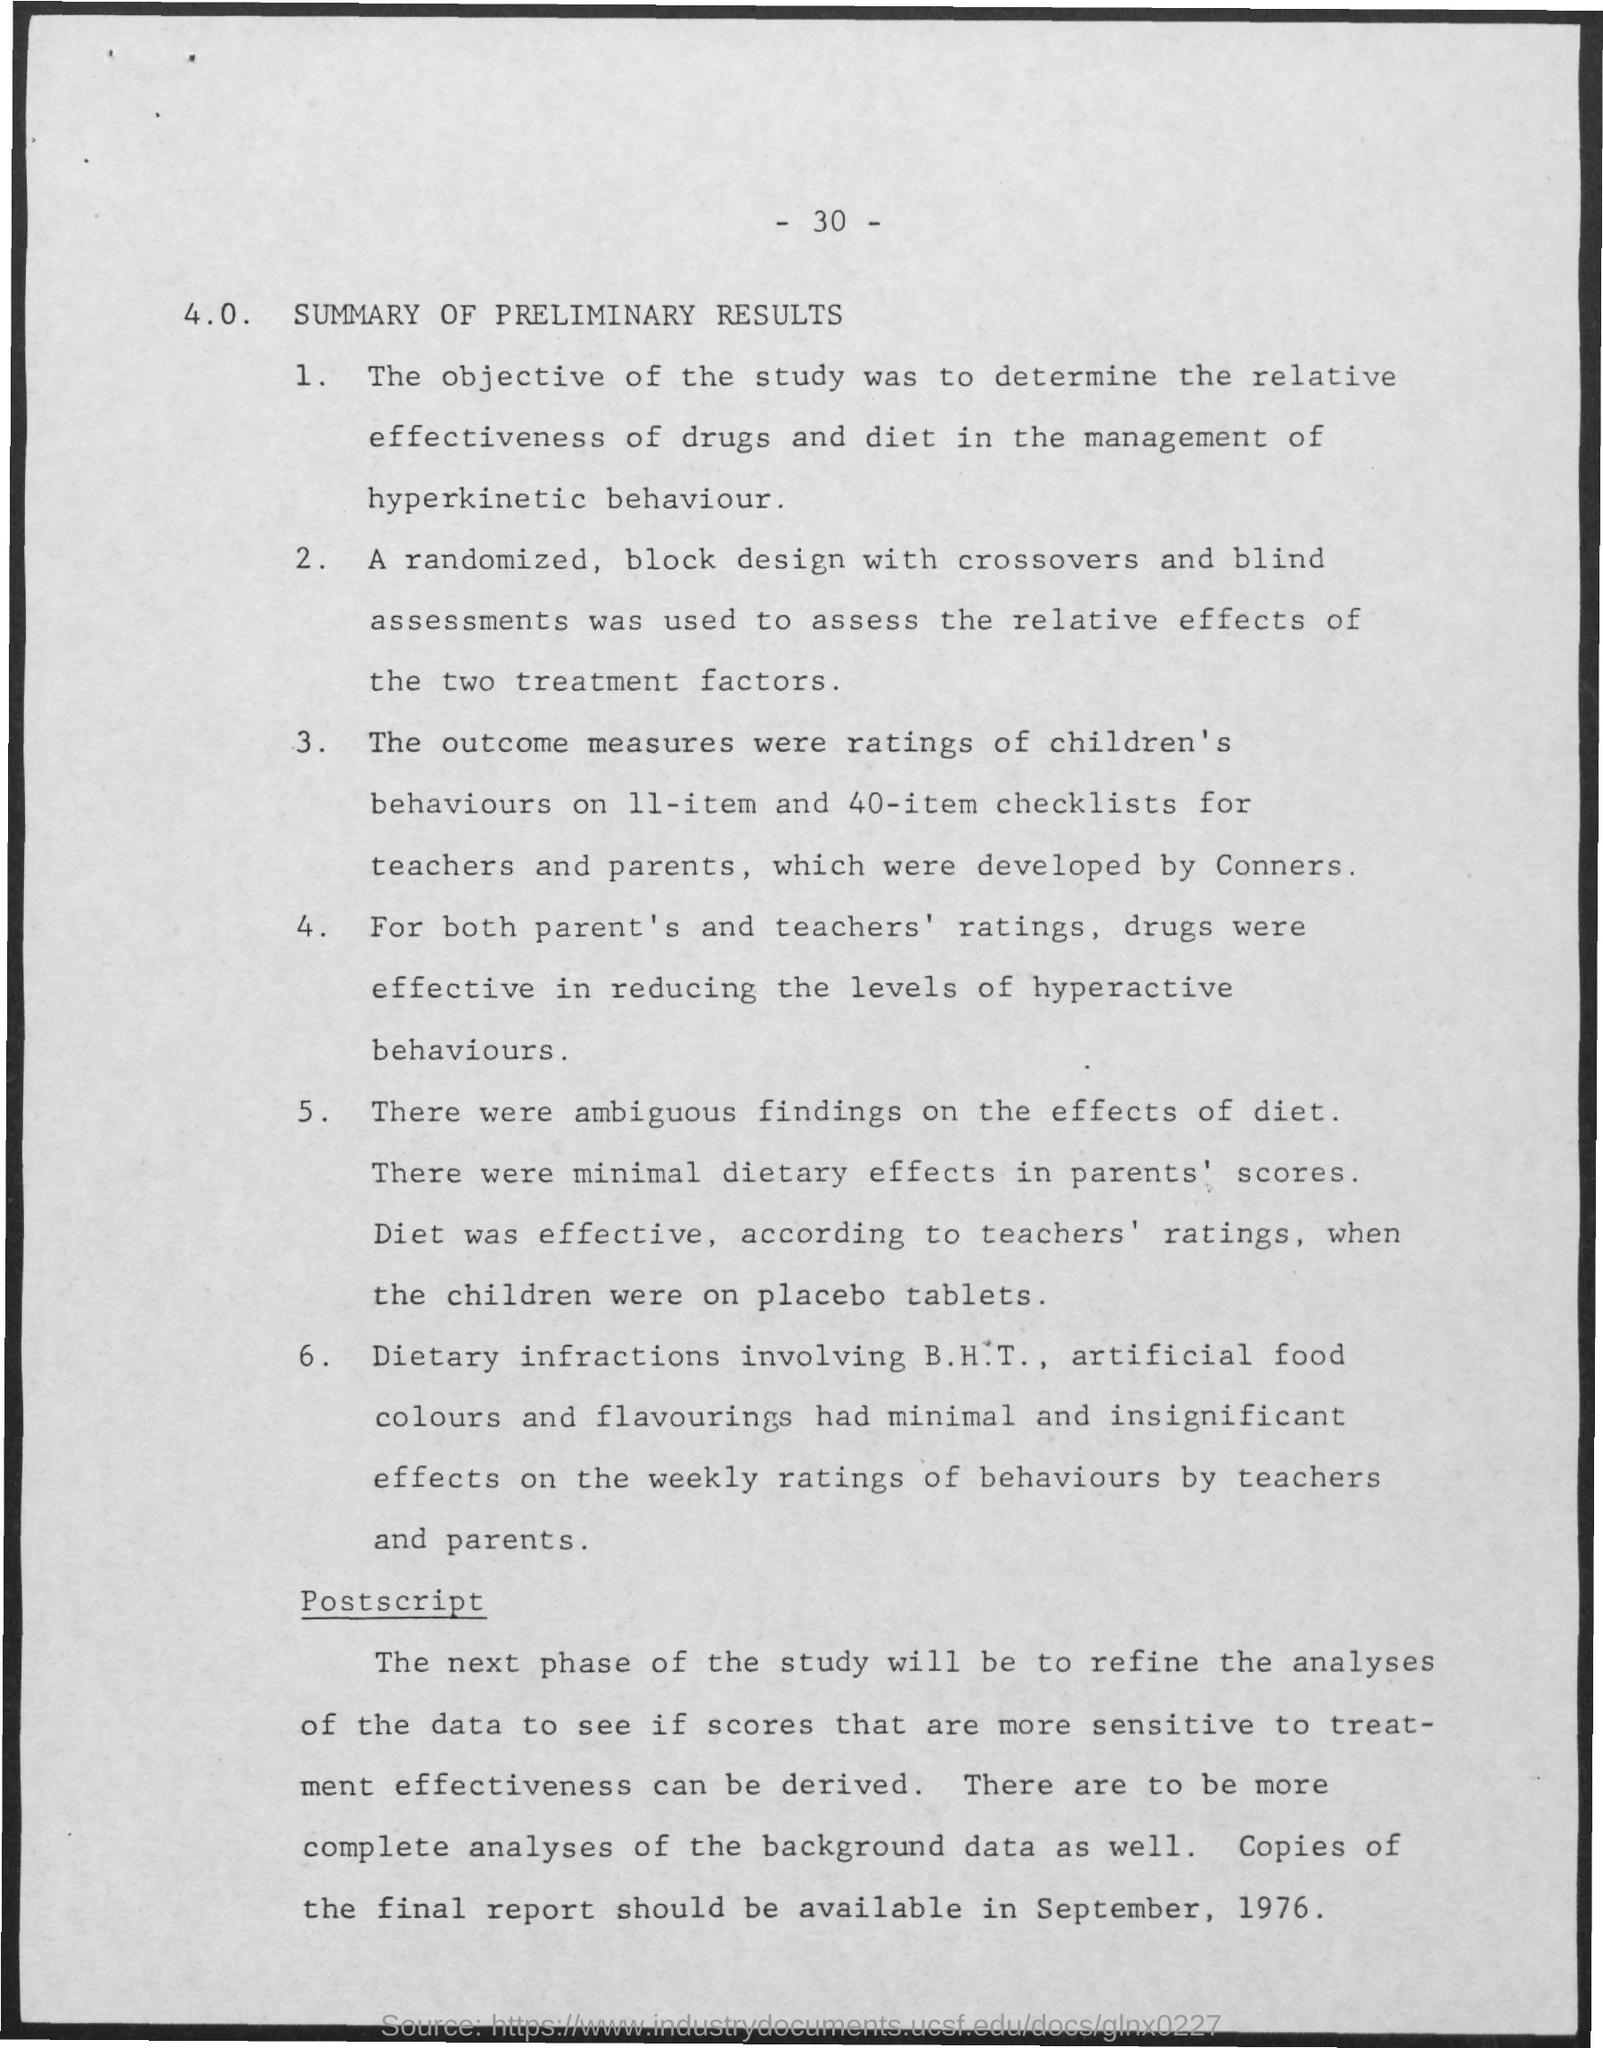The objective of the study was to determine the relative effectiveness of drugs and diet in the management of what?
Give a very brief answer. Hyperkinetic behaviour. What is the Page Number?
Your answer should be compact. 30. 